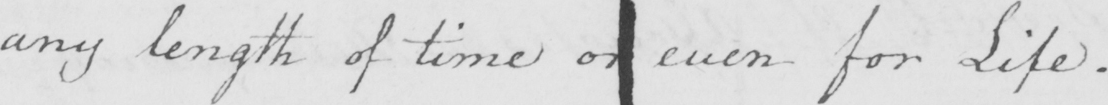What does this handwritten line say? any length of time or even for Life . 